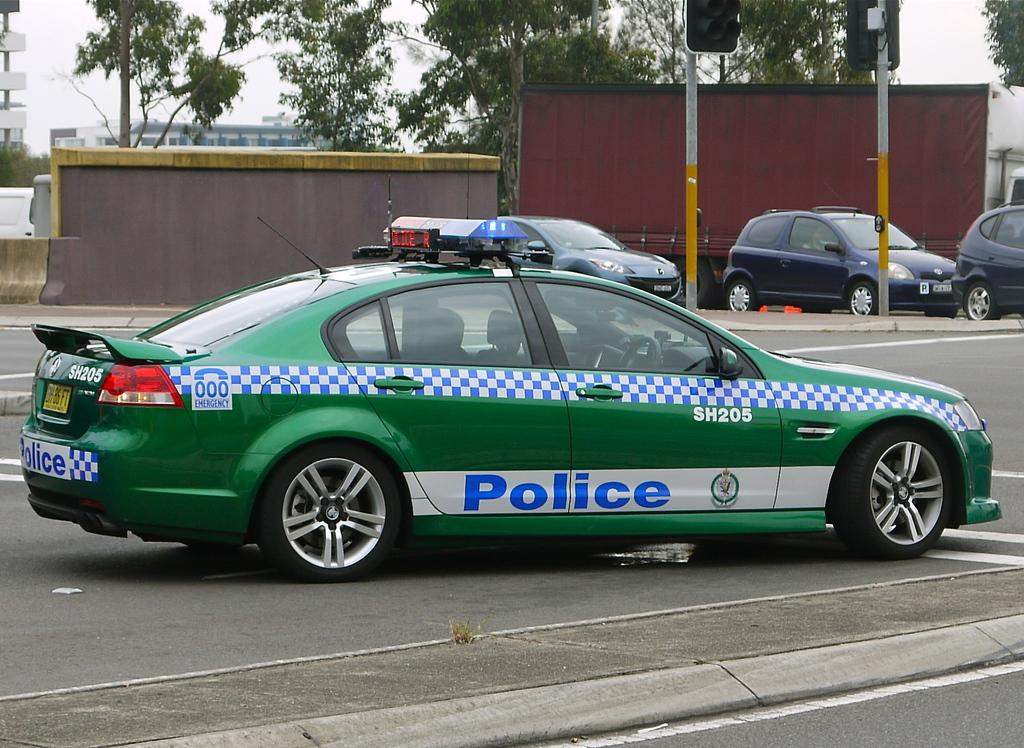<image>
Render a clear and concise summary of the photo. A green car is in an intersection and says Police on the side of it in blue letters. 